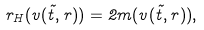Convert formula to latex. <formula><loc_0><loc_0><loc_500><loc_500>r _ { H } ( v ( \tilde { t } , r ) ) = 2 m ( v ( \tilde { t } , r ) ) ,</formula> 